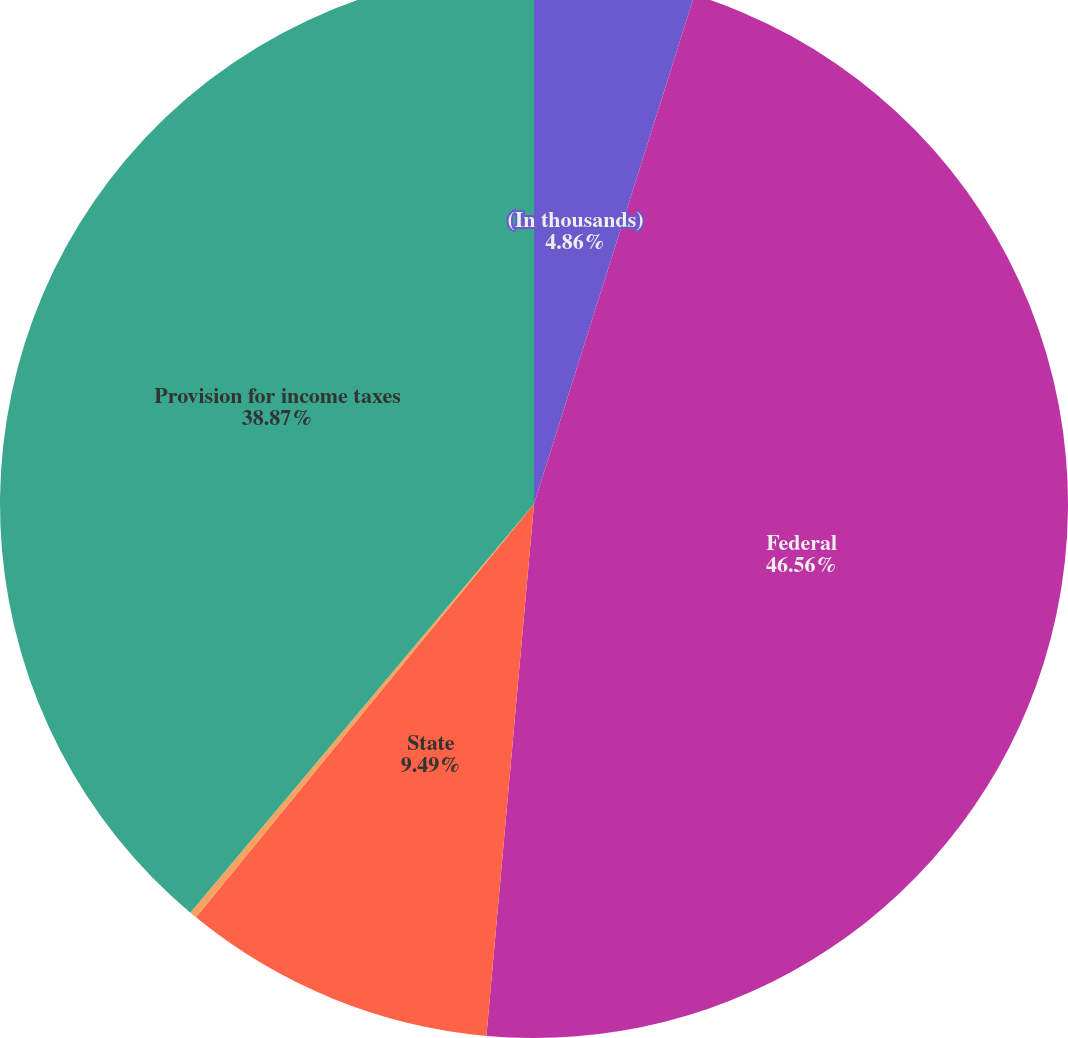<chart> <loc_0><loc_0><loc_500><loc_500><pie_chart><fcel>(In thousands)<fcel>Federal<fcel>State<fcel>Other foreign countries<fcel>Provision for income taxes<nl><fcel>4.86%<fcel>46.56%<fcel>9.49%<fcel>0.22%<fcel>38.87%<nl></chart> 